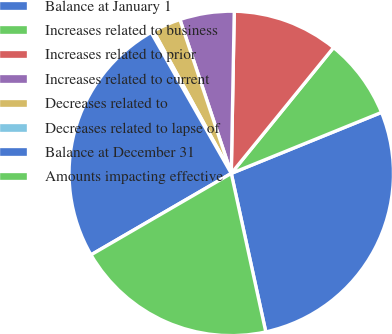Convert chart to OTSL. <chart><loc_0><loc_0><loc_500><loc_500><pie_chart><fcel>Balance at January 1<fcel>Increases related to business<fcel>Increases related to prior<fcel>Increases related to current<fcel>Decreases related to<fcel>Decreases related to lapse of<fcel>Balance at December 31<fcel>Amounts impacting effective<nl><fcel>27.73%<fcel>8.0%<fcel>10.57%<fcel>5.42%<fcel>2.84%<fcel>0.26%<fcel>25.15%<fcel>20.05%<nl></chart> 